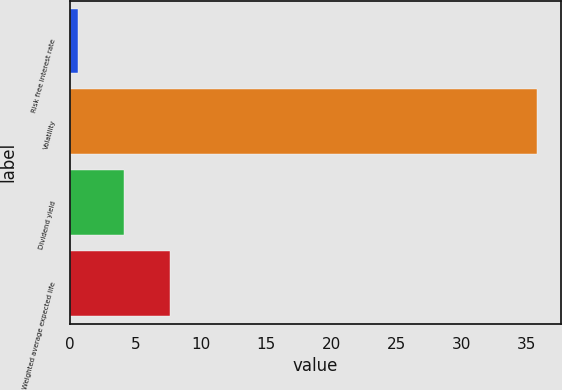Convert chart to OTSL. <chart><loc_0><loc_0><loc_500><loc_500><bar_chart><fcel>Risk free interest rate<fcel>Volatility<fcel>Dividend yield<fcel>Weighted average expected life<nl><fcel>0.6<fcel>35.8<fcel>4.12<fcel>7.64<nl></chart> 